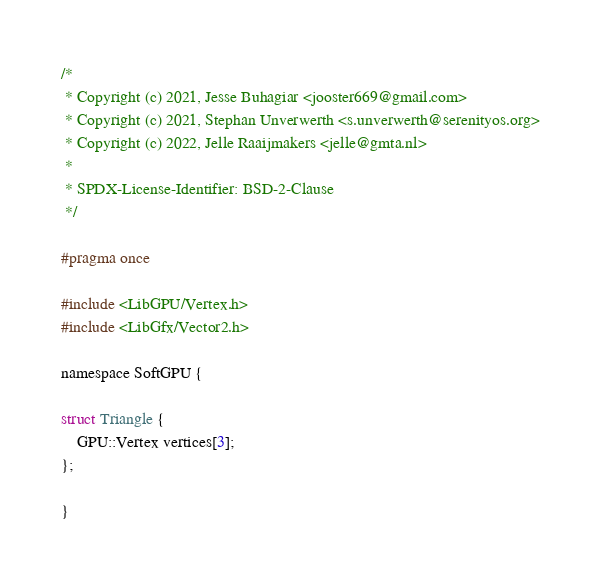<code> <loc_0><loc_0><loc_500><loc_500><_C_>/*
 * Copyright (c) 2021, Jesse Buhagiar <jooster669@gmail.com>
 * Copyright (c) 2021, Stephan Unverwerth <s.unverwerth@serenityos.org>
 * Copyright (c) 2022, Jelle Raaijmakers <jelle@gmta.nl>
 *
 * SPDX-License-Identifier: BSD-2-Clause
 */

#pragma once

#include <LibGPU/Vertex.h>
#include <LibGfx/Vector2.h>

namespace SoftGPU {

struct Triangle {
    GPU::Vertex vertices[3];
};

}
</code> 